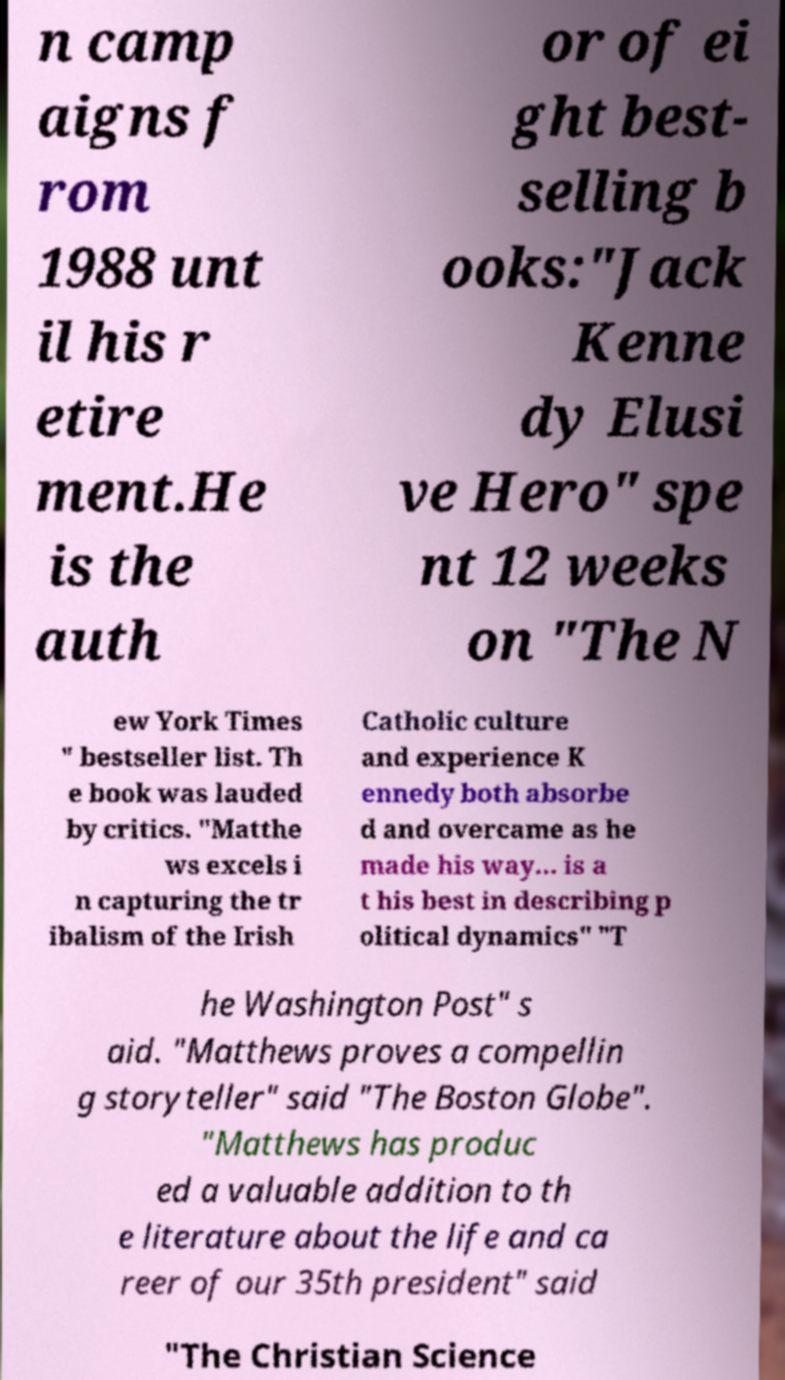For documentation purposes, I need the text within this image transcribed. Could you provide that? n camp aigns f rom 1988 unt il his r etire ment.He is the auth or of ei ght best- selling b ooks:"Jack Kenne dy Elusi ve Hero" spe nt 12 weeks on "The N ew York Times " bestseller list. Th e book was lauded by critics. "Matthe ws excels i n capturing the tr ibalism of the Irish Catholic culture and experience K ennedy both absorbe d and overcame as he made his way... is a t his best in describing p olitical dynamics" "T he Washington Post" s aid. "Matthews proves a compellin g storyteller" said "The Boston Globe". "Matthews has produc ed a valuable addition to th e literature about the life and ca reer of our 35th president" said "The Christian Science 